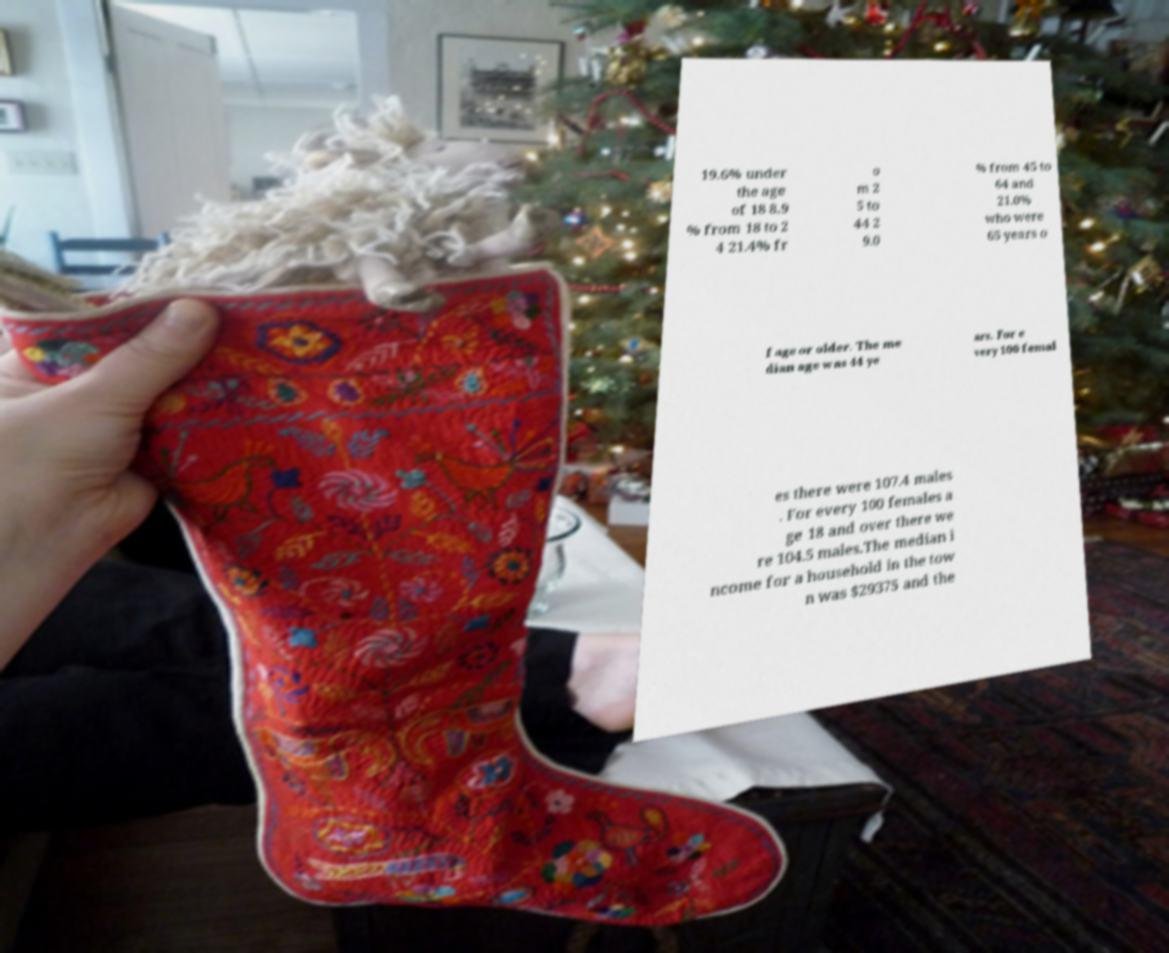What messages or text are displayed in this image? I need them in a readable, typed format. 19.6% under the age of 18 8.9 % from 18 to 2 4 21.4% fr o m 2 5 to 44 2 9.0 % from 45 to 64 and 21.0% who were 65 years o f age or older. The me dian age was 44 ye ars. For e very 100 femal es there were 107.4 males . For every 100 females a ge 18 and over there we re 104.5 males.The median i ncome for a household in the tow n was $29375 and the 